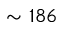Convert formula to latex. <formula><loc_0><loc_0><loc_500><loc_500>\sim 1 8 6</formula> 